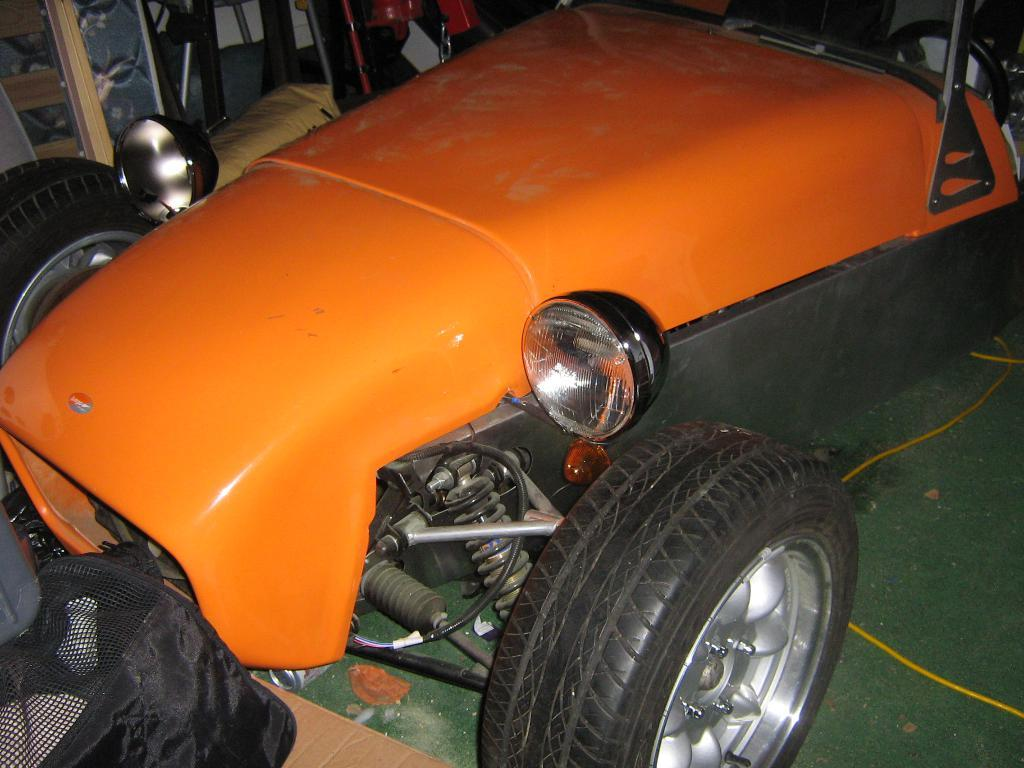What type of vehicle is in the picture? There is an open wheel car in the picture. Can you describe any other objects in the image? There is a black color bag on the left side of the image. What type of toys can be seen in the image? There are no toys present in the image. Can you hear the sound of thunder in the image? There is no sound or reference to thunder in the image. 